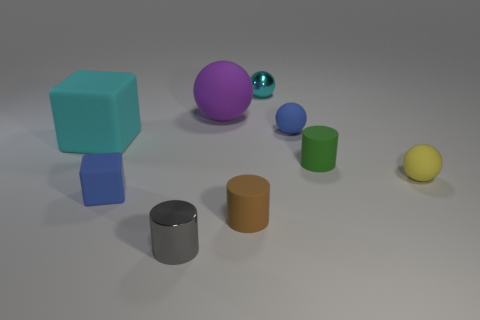Subtract all brown cylinders. How many cylinders are left? 2 Subtract 1 cylinders. How many cylinders are left? 2 Subtract all brown cylinders. How many cylinders are left? 2 Subtract all blocks. How many objects are left? 7 Subtract all blue balls. Subtract all brown blocks. How many balls are left? 3 Subtract all blue rubber blocks. Subtract all metal cylinders. How many objects are left? 7 Add 8 small brown matte cylinders. How many small brown matte cylinders are left? 9 Add 9 brown metal blocks. How many brown metal blocks exist? 9 Subtract 1 yellow spheres. How many objects are left? 8 